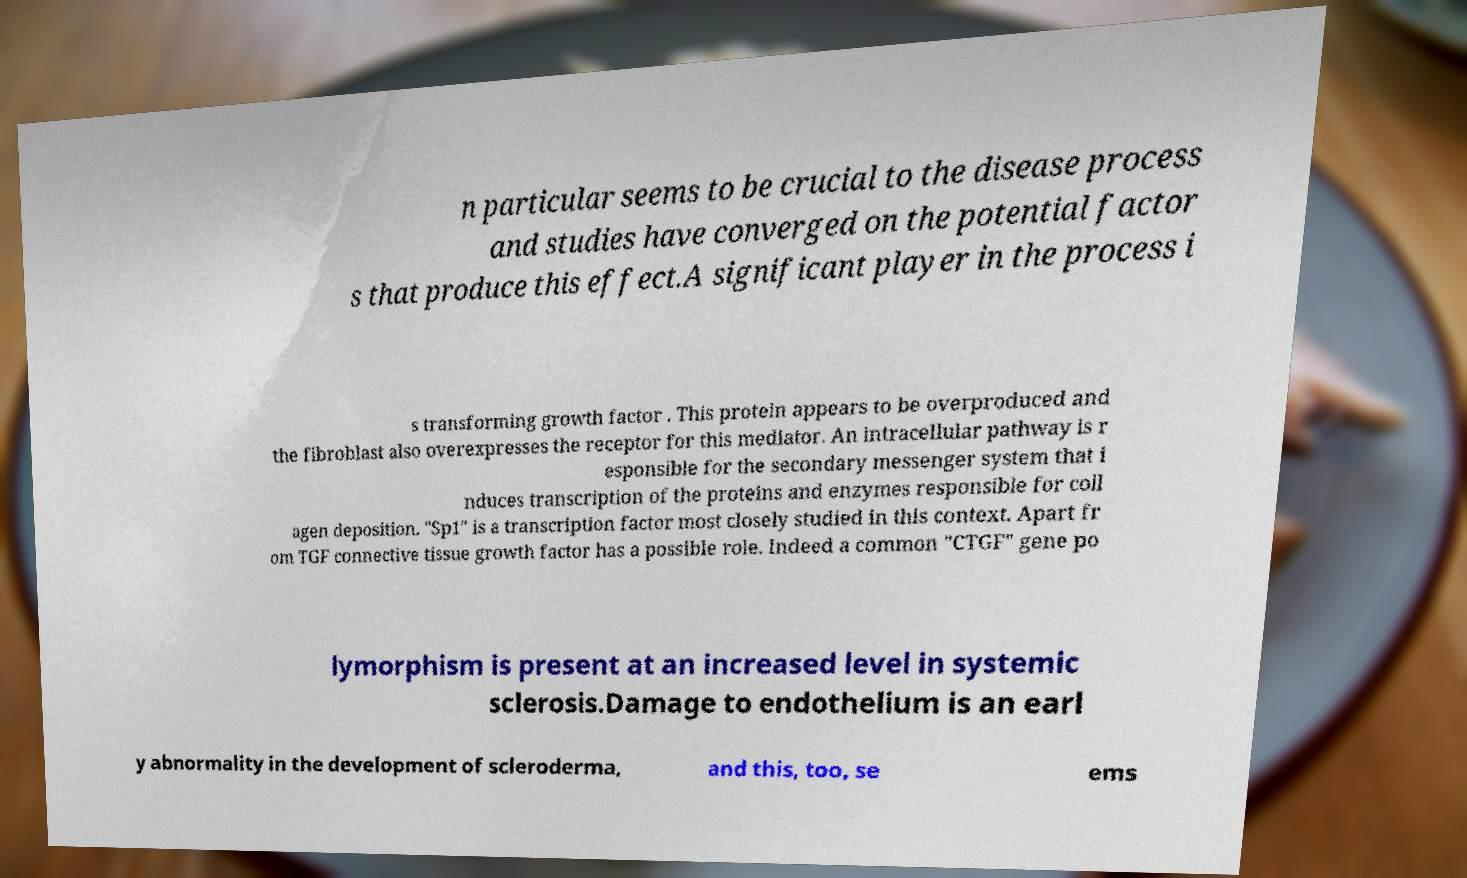What messages or text are displayed in this image? I need them in a readable, typed format. n particular seems to be crucial to the disease process and studies have converged on the potential factor s that produce this effect.A significant player in the process i s transforming growth factor . This protein appears to be overproduced and the fibroblast also overexpresses the receptor for this mediator. An intracellular pathway is r esponsible for the secondary messenger system that i nduces transcription of the proteins and enzymes responsible for coll agen deposition. "Sp1" is a transcription factor most closely studied in this context. Apart fr om TGF connective tissue growth factor has a possible role. Indeed a common "CTGF" gene po lymorphism is present at an increased level in systemic sclerosis.Damage to endothelium is an earl y abnormality in the development of scleroderma, and this, too, se ems 